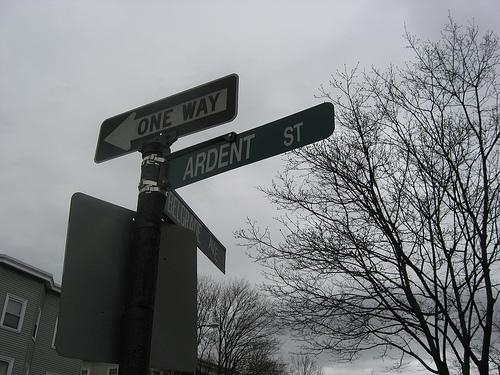Describe the overall atmosphere of the image. The image portrays an overcast day with leafless trees, suggesting it might be winter, and includes several street signs and a light-colored building. Mention the most notable features of this image. The image features various street signs, a pole with many signs attached, leafless trees, and a light-colored building with a rectangular window. Describe the image as if you were writing a brief paragraph for an article in a magazine. Captured on a cold, overcast day with a backdrop of leafless trees, the image highlights the diverse signage that adorns a single thick metal pole. Nestled among the trees, light-colored houses provide a serene setting for the complex arrangement of street signs. Narrate what you see in the image in a storytelling manner. On a grey and overcast winter day, a thick metal pole stands tall, covered with an assortment of street signs. Nearby, leafless trees and light-colored houses line the street. If this image were a photograph, what title would you give it? "Signposts and Serenity - Winter on a Suburban Street" Provide a brief description of the primary objects in the image. The image contains a black and white traffic sign, two green and white street signs, a rectangular traffic sign on a pole, leafless trees, and light-colored houses. Imagine you are describing this image to a friend over a call. What would you say? Hey, I'm looking at a picture where there's a pole with several street signs, and it looks like a cold, overcast day. There are some leafless trees and light-colored houses too. List the main elements you observe in the image. Overcast sky, a black and white traffic sign, green and white street signs, pole with signs, leafless trees, light-colored houses, rectangular windows. In a single sentence, capture the essence of the image. An overcast winter day sets the stage for a collection of street signs and leafless trees, surrounding the quiet homes of a suburban neighborhood. Provide a creative and poetic description of the image. In a monochromatic world of grey skies and barren trees, a chorus of street signs sings directions from their perch upon a sturdy metal pole. The quiet street they guide is lined with muted, light-hued homes. 